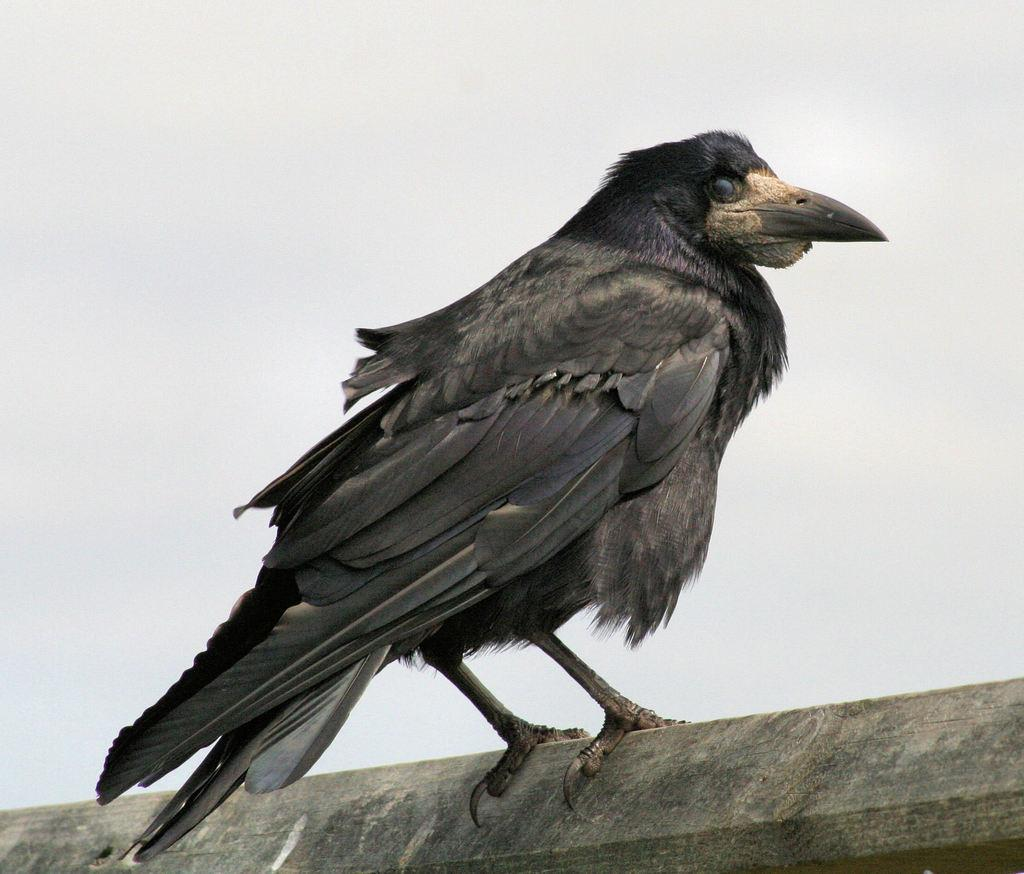What type of bird is in the image? There is a crow in the image. Where is the crow located in the image? The crow is standing on a wall. What shape is the sand in the image? There is no sand present in the image; it features a crow standing on a wall. 